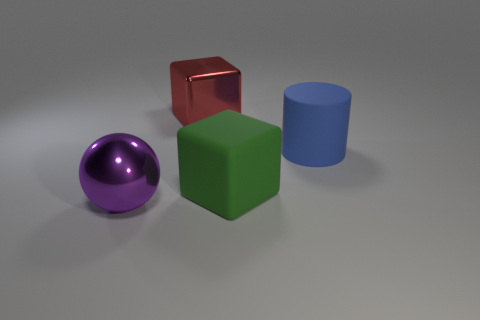Are there any purple metal balls of the same size as the green block?
Provide a short and direct response. Yes. What material is the purple ball that is the same size as the rubber cylinder?
Offer a terse response. Metal. How many small red matte blocks are there?
Make the answer very short. 0. Are there an equal number of purple objects that are right of the purple metal object and large cyan shiny objects?
Your answer should be very brief. Yes. Are there any metallic things that have the same shape as the large green matte thing?
Provide a short and direct response. Yes. What shape is the large thing that is behind the big purple object and in front of the cylinder?
Give a very brief answer. Cube. Is the cylinder made of the same material as the red thing on the left side of the large blue object?
Keep it short and to the point. No. Are there any big things on the left side of the blue cylinder?
Make the answer very short. Yes. How many objects are large purple shiny balls or big cubes that are in front of the metal cube?
Give a very brief answer. 2. The large thing that is to the left of the big metal thing behind the large purple shiny thing is what color?
Your answer should be very brief. Purple. 